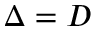Convert formula to latex. <formula><loc_0><loc_0><loc_500><loc_500>\Delta = D</formula> 